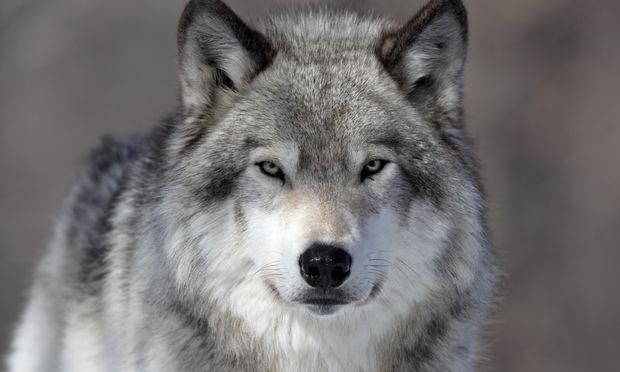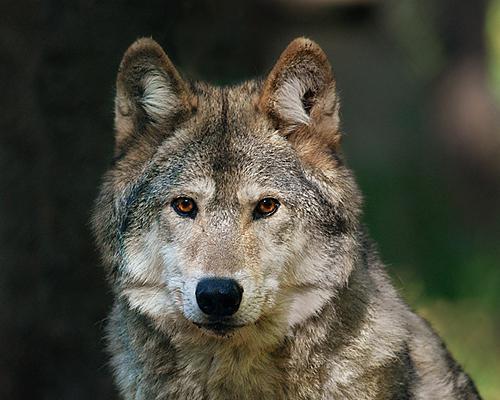The first image is the image on the left, the second image is the image on the right. For the images displayed, is the sentence "An image shows at least one wolf gazing directly leftward." factually correct? Answer yes or no. No. The first image is the image on the left, the second image is the image on the right. Considering the images on both sides, is "The wild dog looks straight toward the camera." valid? Answer yes or no. Yes. 